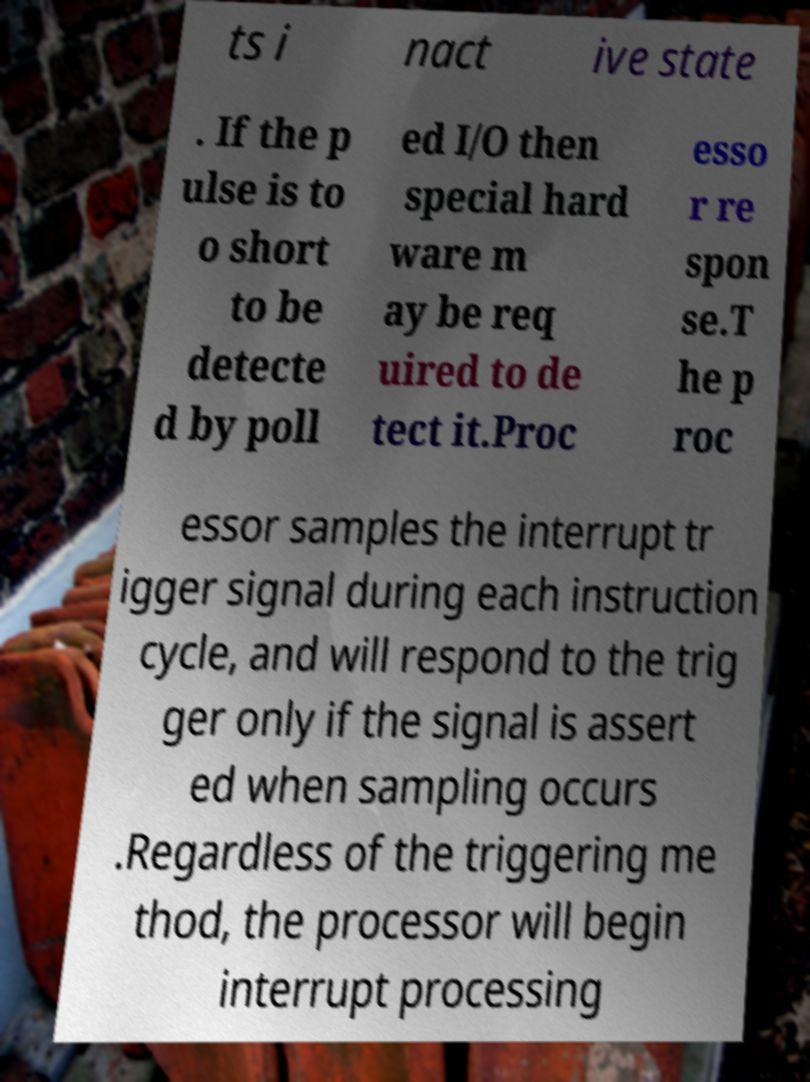Could you extract and type out the text from this image? ts i nact ive state . If the p ulse is to o short to be detecte d by poll ed I/O then special hard ware m ay be req uired to de tect it.Proc esso r re spon se.T he p roc essor samples the interrupt tr igger signal during each instruction cycle, and will respond to the trig ger only if the signal is assert ed when sampling occurs .Regardless of the triggering me thod, the processor will begin interrupt processing 